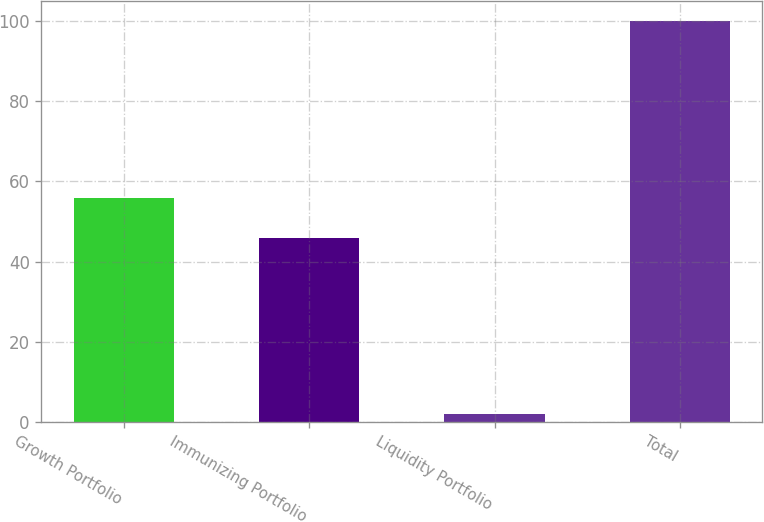Convert chart. <chart><loc_0><loc_0><loc_500><loc_500><bar_chart><fcel>Growth Portfolio<fcel>Immunizing Portfolio<fcel>Liquidity Portfolio<fcel>Total<nl><fcel>55.8<fcel>46<fcel>2<fcel>100<nl></chart> 